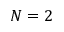<formula> <loc_0><loc_0><loc_500><loc_500>N = 2</formula> 